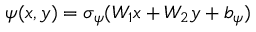<formula> <loc_0><loc_0><loc_500><loc_500>\psi ( x , y ) = \sigma _ { \psi } ( W _ { 1 } x + W _ { 2 } y + b _ { \psi } )</formula> 